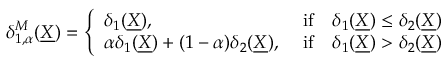<formula> <loc_0><loc_0><loc_500><loc_500>\begin{array} { r } { \delta _ { 1 , \alpha } ^ { M } ( \underline { X } ) = \left \{ \begin{array} { l l } { \delta _ { 1 } ( \underline { X } ) , } & { i f \quad \delta _ { 1 } ( \underline { X } ) \leq \delta _ { 2 } ( \underline { X } ) } \\ { \alpha \delta _ { 1 } ( \underline { X } ) + ( 1 - \alpha ) \delta _ { 2 } ( \underline { X } ) , } & { i f \quad \delta _ { 1 } ( \underline { X } ) > \delta _ { 2 } ( \underline { X } ) } \end{array} } \end{array}</formula> 